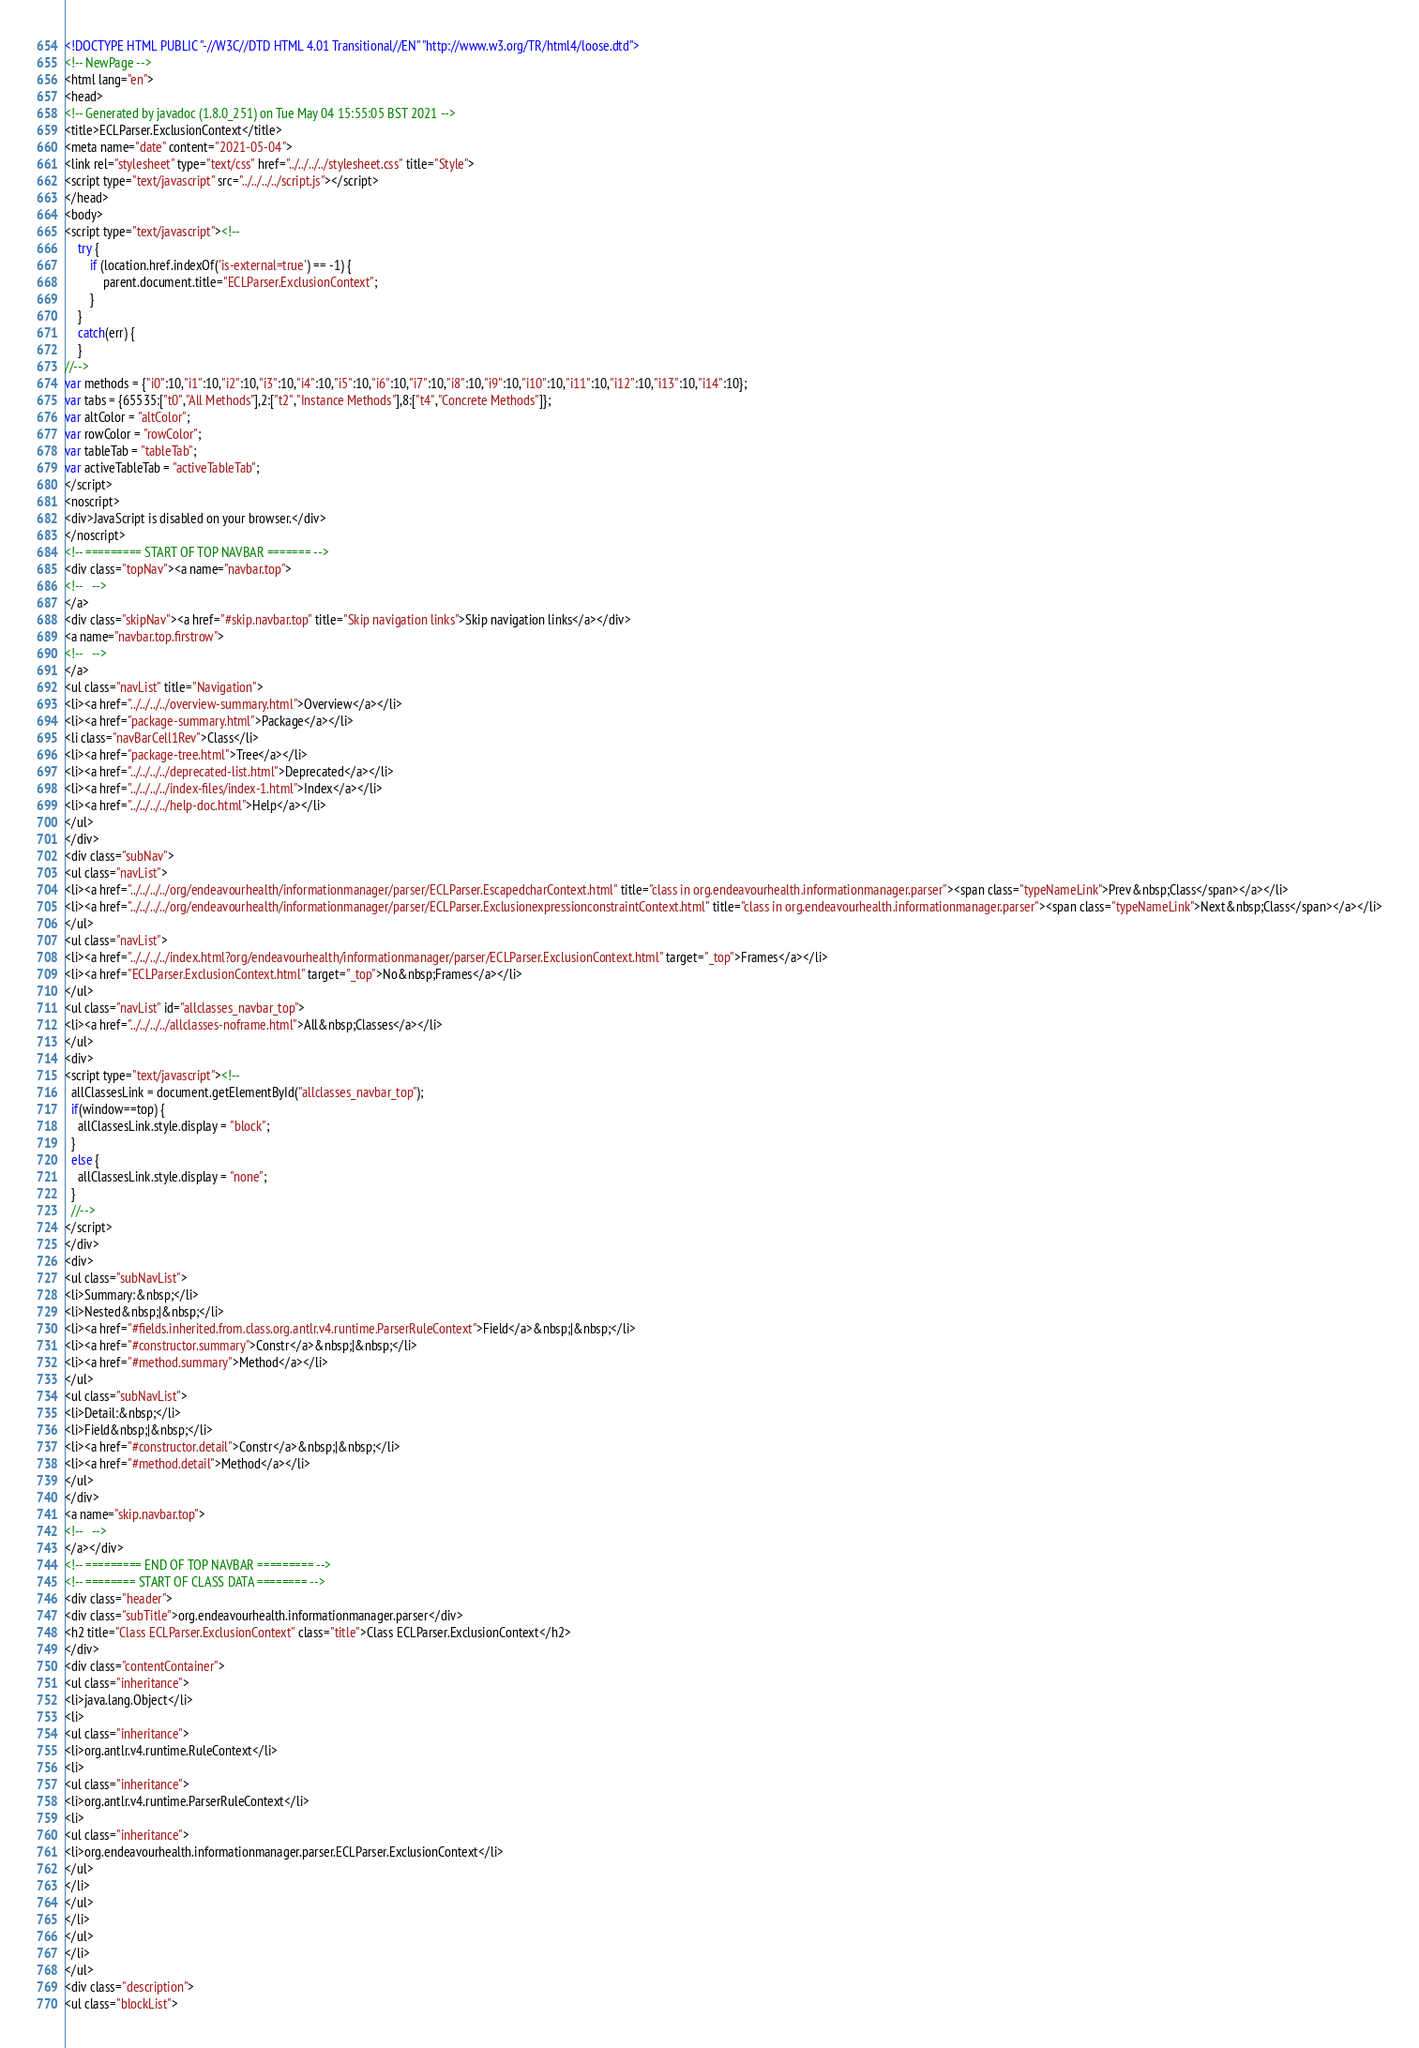<code> <loc_0><loc_0><loc_500><loc_500><_HTML_><!DOCTYPE HTML PUBLIC "-//W3C//DTD HTML 4.01 Transitional//EN" "http://www.w3.org/TR/html4/loose.dtd">
<!-- NewPage -->
<html lang="en">
<head>
<!-- Generated by javadoc (1.8.0_251) on Tue May 04 15:55:05 BST 2021 -->
<title>ECLParser.ExclusionContext</title>
<meta name="date" content="2021-05-04">
<link rel="stylesheet" type="text/css" href="../../../../stylesheet.css" title="Style">
<script type="text/javascript" src="../../../../script.js"></script>
</head>
<body>
<script type="text/javascript"><!--
    try {
        if (location.href.indexOf('is-external=true') == -1) {
            parent.document.title="ECLParser.ExclusionContext";
        }
    }
    catch(err) {
    }
//-->
var methods = {"i0":10,"i1":10,"i2":10,"i3":10,"i4":10,"i5":10,"i6":10,"i7":10,"i8":10,"i9":10,"i10":10,"i11":10,"i12":10,"i13":10,"i14":10};
var tabs = {65535:["t0","All Methods"],2:["t2","Instance Methods"],8:["t4","Concrete Methods"]};
var altColor = "altColor";
var rowColor = "rowColor";
var tableTab = "tableTab";
var activeTableTab = "activeTableTab";
</script>
<noscript>
<div>JavaScript is disabled on your browser.</div>
</noscript>
<!-- ========= START OF TOP NAVBAR ======= -->
<div class="topNav"><a name="navbar.top">
<!--   -->
</a>
<div class="skipNav"><a href="#skip.navbar.top" title="Skip navigation links">Skip navigation links</a></div>
<a name="navbar.top.firstrow">
<!--   -->
</a>
<ul class="navList" title="Navigation">
<li><a href="../../../../overview-summary.html">Overview</a></li>
<li><a href="package-summary.html">Package</a></li>
<li class="navBarCell1Rev">Class</li>
<li><a href="package-tree.html">Tree</a></li>
<li><a href="../../../../deprecated-list.html">Deprecated</a></li>
<li><a href="../../../../index-files/index-1.html">Index</a></li>
<li><a href="../../../../help-doc.html">Help</a></li>
</ul>
</div>
<div class="subNav">
<ul class="navList">
<li><a href="../../../../org/endeavourhealth/informationmanager/parser/ECLParser.EscapedcharContext.html" title="class in org.endeavourhealth.informationmanager.parser"><span class="typeNameLink">Prev&nbsp;Class</span></a></li>
<li><a href="../../../../org/endeavourhealth/informationmanager/parser/ECLParser.ExclusionexpressionconstraintContext.html" title="class in org.endeavourhealth.informationmanager.parser"><span class="typeNameLink">Next&nbsp;Class</span></a></li>
</ul>
<ul class="navList">
<li><a href="../../../../index.html?org/endeavourhealth/informationmanager/parser/ECLParser.ExclusionContext.html" target="_top">Frames</a></li>
<li><a href="ECLParser.ExclusionContext.html" target="_top">No&nbsp;Frames</a></li>
</ul>
<ul class="navList" id="allclasses_navbar_top">
<li><a href="../../../../allclasses-noframe.html">All&nbsp;Classes</a></li>
</ul>
<div>
<script type="text/javascript"><!--
  allClassesLink = document.getElementById("allclasses_navbar_top");
  if(window==top) {
    allClassesLink.style.display = "block";
  }
  else {
    allClassesLink.style.display = "none";
  }
  //-->
</script>
</div>
<div>
<ul class="subNavList">
<li>Summary:&nbsp;</li>
<li>Nested&nbsp;|&nbsp;</li>
<li><a href="#fields.inherited.from.class.org.antlr.v4.runtime.ParserRuleContext">Field</a>&nbsp;|&nbsp;</li>
<li><a href="#constructor.summary">Constr</a>&nbsp;|&nbsp;</li>
<li><a href="#method.summary">Method</a></li>
</ul>
<ul class="subNavList">
<li>Detail:&nbsp;</li>
<li>Field&nbsp;|&nbsp;</li>
<li><a href="#constructor.detail">Constr</a>&nbsp;|&nbsp;</li>
<li><a href="#method.detail">Method</a></li>
</ul>
</div>
<a name="skip.navbar.top">
<!--   -->
</a></div>
<!-- ========= END OF TOP NAVBAR ========= -->
<!-- ======== START OF CLASS DATA ======== -->
<div class="header">
<div class="subTitle">org.endeavourhealth.informationmanager.parser</div>
<h2 title="Class ECLParser.ExclusionContext" class="title">Class ECLParser.ExclusionContext</h2>
</div>
<div class="contentContainer">
<ul class="inheritance">
<li>java.lang.Object</li>
<li>
<ul class="inheritance">
<li>org.antlr.v4.runtime.RuleContext</li>
<li>
<ul class="inheritance">
<li>org.antlr.v4.runtime.ParserRuleContext</li>
<li>
<ul class="inheritance">
<li>org.endeavourhealth.informationmanager.parser.ECLParser.ExclusionContext</li>
</ul>
</li>
</ul>
</li>
</ul>
</li>
</ul>
<div class="description">
<ul class="blockList"></code> 